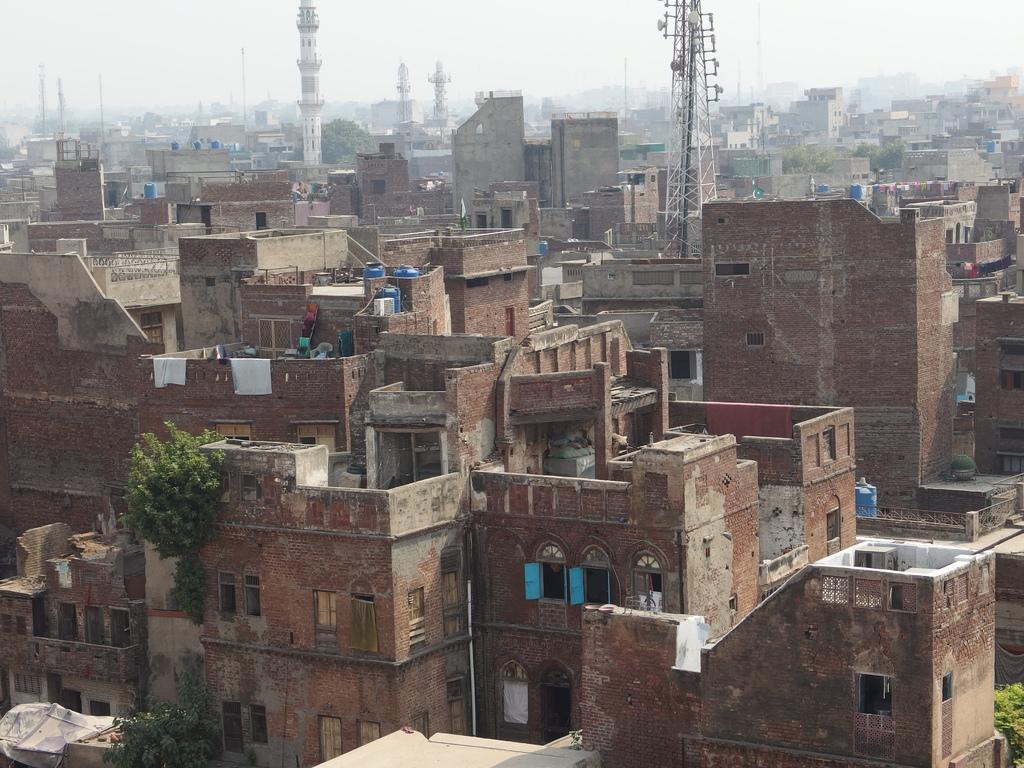Could you give a brief overview of what you see in this image? In this image there are so many brick buildings in the middle. At the top there is a tower. In this image we can see the view of the city where there are so many buildings on which there are clothes and water tanks. 